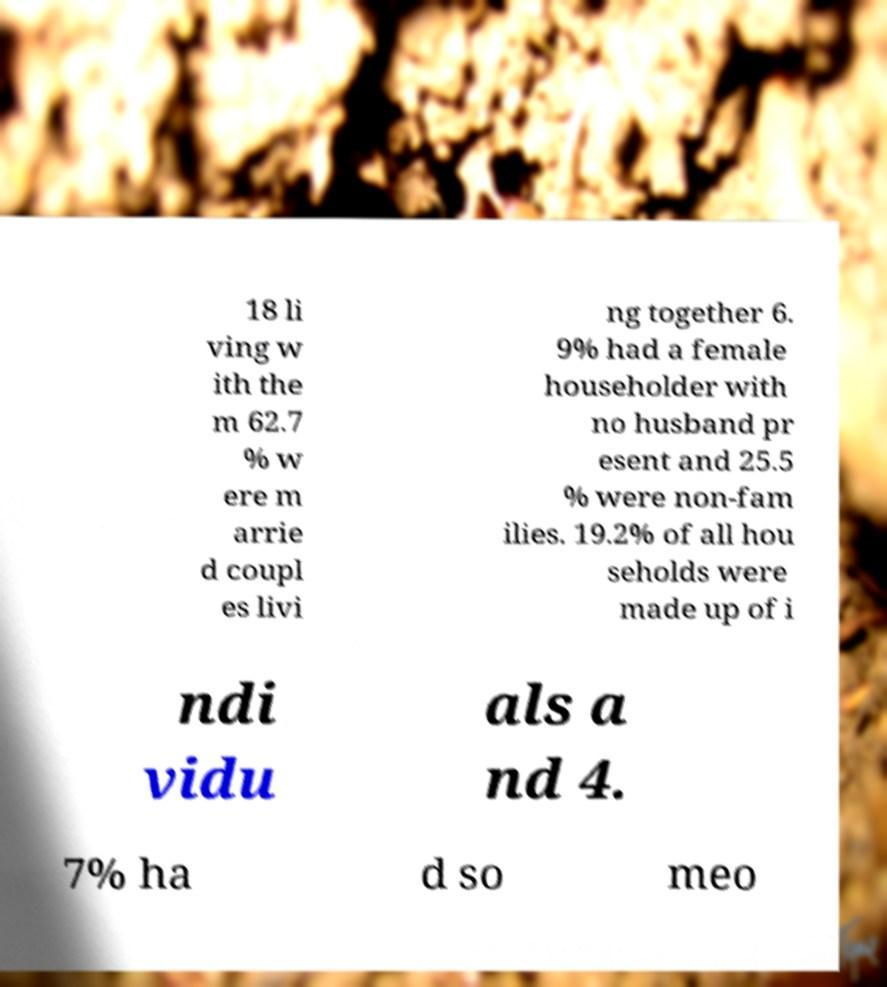Can you read and provide the text displayed in the image?This photo seems to have some interesting text. Can you extract and type it out for me? 18 li ving w ith the m 62.7 % w ere m arrie d coupl es livi ng together 6. 9% had a female householder with no husband pr esent and 25.5 % were non-fam ilies. 19.2% of all hou seholds were made up of i ndi vidu als a nd 4. 7% ha d so meo 